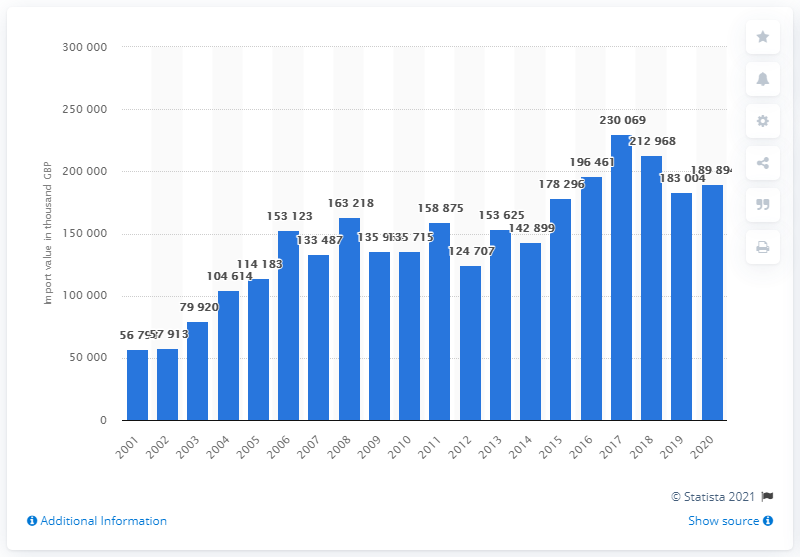Highlight a few significant elements in this photo. In the year when imports of olive oil were valued at approximately 190 million British pounds, it was 2020. 